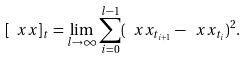<formula> <loc_0><loc_0><loc_500><loc_500>[ { \ x x } ] _ { t } = \lim _ { l \to \infty } \sum _ { i = 0 } ^ { l - 1 } ( \ x x _ { t _ { i + 1 } } - \ x x _ { t _ { i } } ) ^ { 2 } .</formula> 